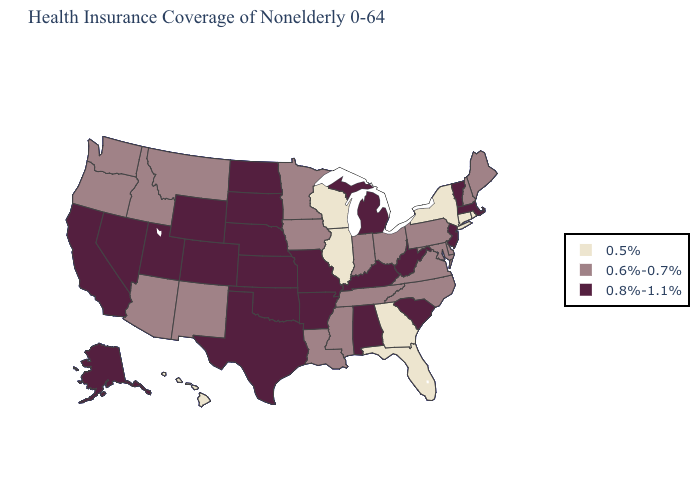Name the states that have a value in the range 0.6%-0.7%?
Write a very short answer. Arizona, Delaware, Idaho, Indiana, Iowa, Louisiana, Maine, Maryland, Minnesota, Mississippi, Montana, New Hampshire, New Mexico, North Carolina, Ohio, Oregon, Pennsylvania, Tennessee, Virginia, Washington. Name the states that have a value in the range 0.5%?
Be succinct. Connecticut, Florida, Georgia, Hawaii, Illinois, New York, Rhode Island, Wisconsin. Does the first symbol in the legend represent the smallest category?
Keep it brief. Yes. What is the lowest value in the MidWest?
Give a very brief answer. 0.5%. How many symbols are there in the legend?
Answer briefly. 3. Does Oregon have the lowest value in the West?
Be succinct. No. What is the highest value in the USA?
Give a very brief answer. 0.8%-1.1%. Among the states that border New Mexico , does Colorado have the lowest value?
Give a very brief answer. No. Is the legend a continuous bar?
Keep it brief. No. What is the value of Alaska?
Concise answer only. 0.8%-1.1%. Name the states that have a value in the range 0.8%-1.1%?
Give a very brief answer. Alabama, Alaska, Arkansas, California, Colorado, Kansas, Kentucky, Massachusetts, Michigan, Missouri, Nebraska, Nevada, New Jersey, North Dakota, Oklahoma, South Carolina, South Dakota, Texas, Utah, Vermont, West Virginia, Wyoming. Does the map have missing data?
Answer briefly. No. Name the states that have a value in the range 0.6%-0.7%?
Quick response, please. Arizona, Delaware, Idaho, Indiana, Iowa, Louisiana, Maine, Maryland, Minnesota, Mississippi, Montana, New Hampshire, New Mexico, North Carolina, Ohio, Oregon, Pennsylvania, Tennessee, Virginia, Washington. Does Alabama have the same value as Arizona?
Answer briefly. No. Does Iowa have the highest value in the USA?
Keep it brief. No. 